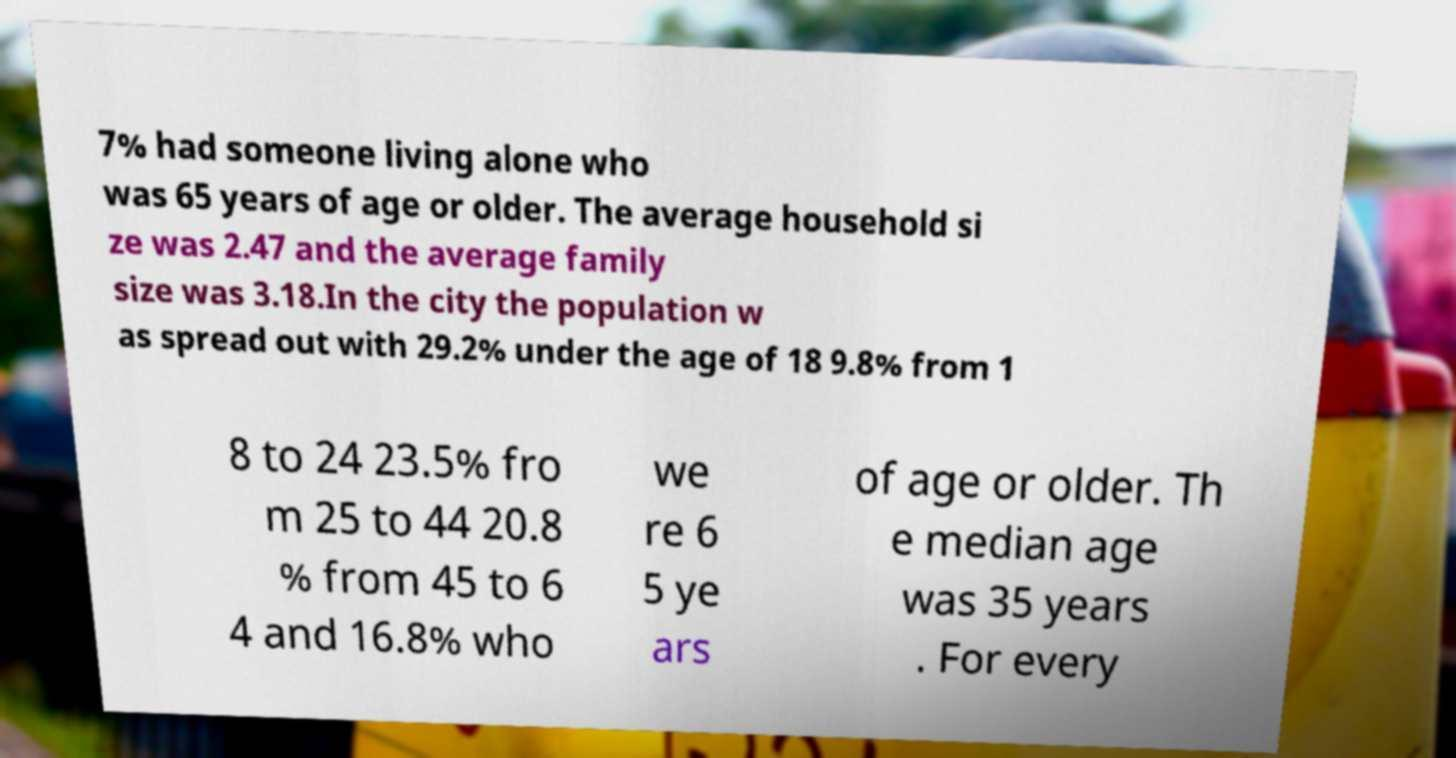What messages or text are displayed in this image? I need them in a readable, typed format. 7% had someone living alone who was 65 years of age or older. The average household si ze was 2.47 and the average family size was 3.18.In the city the population w as spread out with 29.2% under the age of 18 9.8% from 1 8 to 24 23.5% fro m 25 to 44 20.8 % from 45 to 6 4 and 16.8% who we re 6 5 ye ars of age or older. Th e median age was 35 years . For every 